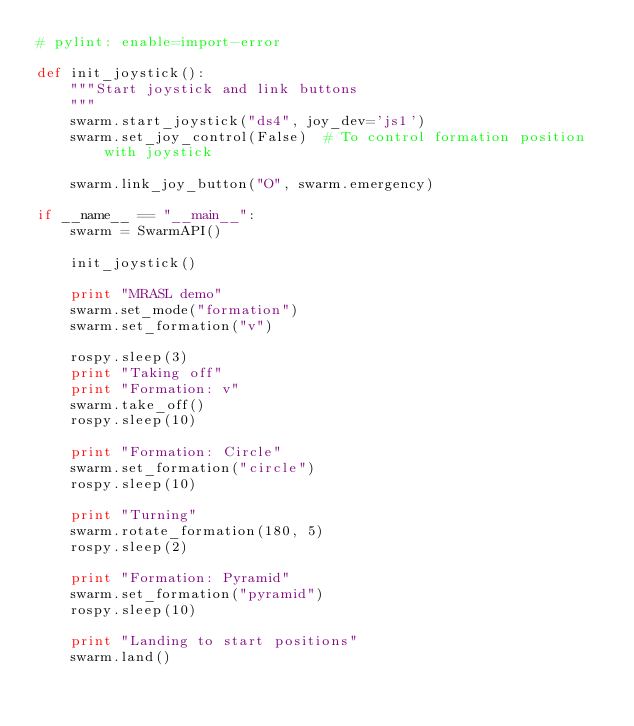<code> <loc_0><loc_0><loc_500><loc_500><_Python_># pylint: enable=import-error

def init_joystick():
    """Start joystick and link buttons
    """
    swarm.start_joystick("ds4", joy_dev='js1')
    swarm.set_joy_control(False)  # To control formation position with joystick

    swarm.link_joy_button("O", swarm.emergency)

if __name__ == "__main__":
    swarm = SwarmAPI()

    init_joystick()

    print "MRASL demo"
    swarm.set_mode("formation")
    swarm.set_formation("v")

    rospy.sleep(3)
    print "Taking off"
    print "Formation: v"
    swarm.take_off()
    rospy.sleep(10)

    print "Formation: Circle"
    swarm.set_formation("circle")
    rospy.sleep(10)

    print "Turning"
    swarm.rotate_formation(180, 5)
    rospy.sleep(2)

    print "Formation: Pyramid"
    swarm.set_formation("pyramid")
    rospy.sleep(10)

    print "Landing to start positions"
    swarm.land()
</code> 